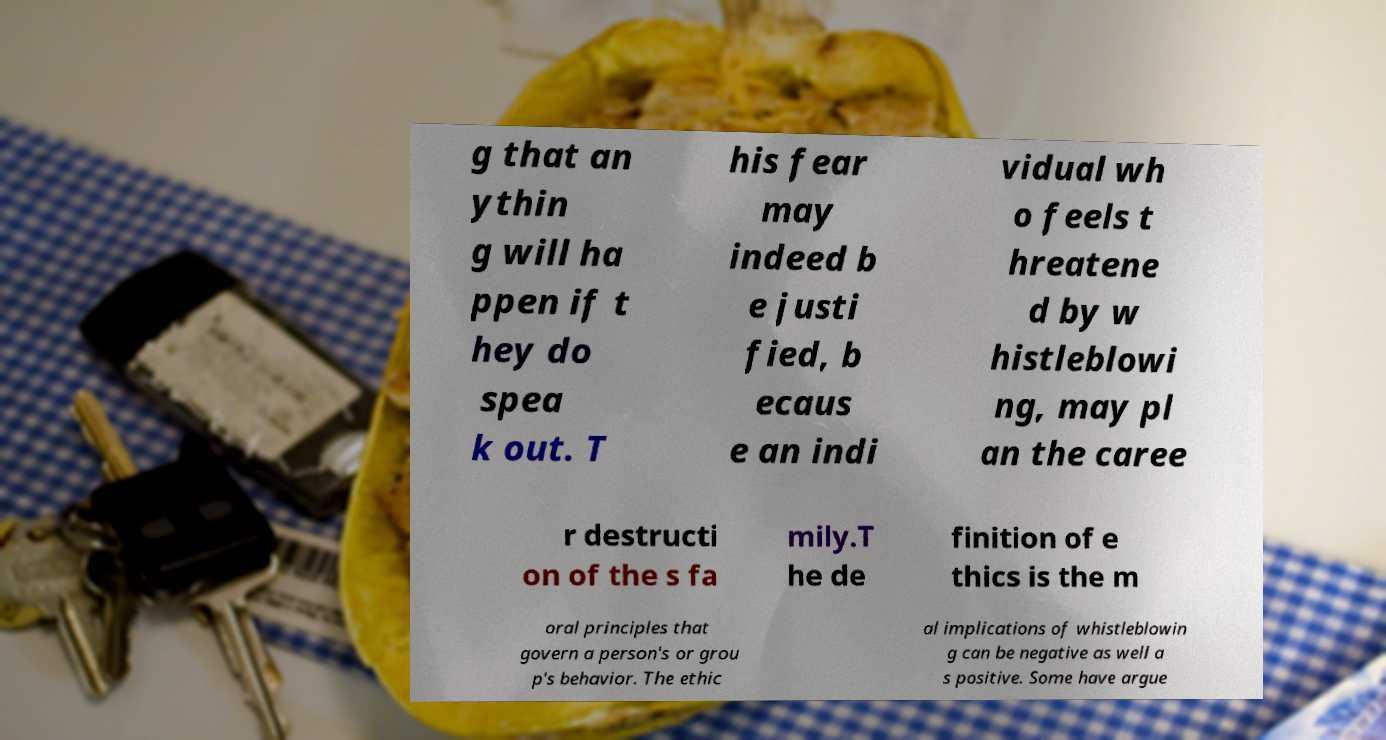Can you accurately transcribe the text from the provided image for me? g that an ythin g will ha ppen if t hey do spea k out. T his fear may indeed b e justi fied, b ecaus e an indi vidual wh o feels t hreatene d by w histleblowi ng, may pl an the caree r destructi on of the s fa mily.T he de finition of e thics is the m oral principles that govern a person's or grou p's behavior. The ethic al implications of whistleblowin g can be negative as well a s positive. Some have argue 